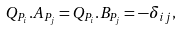<formula> <loc_0><loc_0><loc_500><loc_500>Q _ { P _ { i } } . A _ { P _ { j } } = Q _ { P _ { i } } . B _ { P _ { j } } = - \delta _ { i j } ,</formula> 